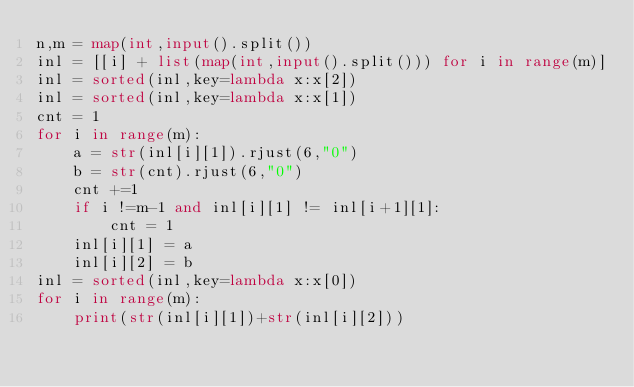<code> <loc_0><loc_0><loc_500><loc_500><_Python_>n,m = map(int,input().split())
inl = [[i] + list(map(int,input().split())) for i in range(m)]
inl = sorted(inl,key=lambda x:x[2])
inl = sorted(inl,key=lambda x:x[1])
cnt = 1
for i in range(m):
    a = str(inl[i][1]).rjust(6,"0")
    b = str(cnt).rjust(6,"0")
    cnt +=1
    if i !=m-1 and inl[i][1] != inl[i+1][1]:
        cnt = 1
    inl[i][1] = a
    inl[i][2] = b
inl = sorted(inl,key=lambda x:x[0])
for i in range(m):
    print(str(inl[i][1])+str(inl[i][2]))</code> 